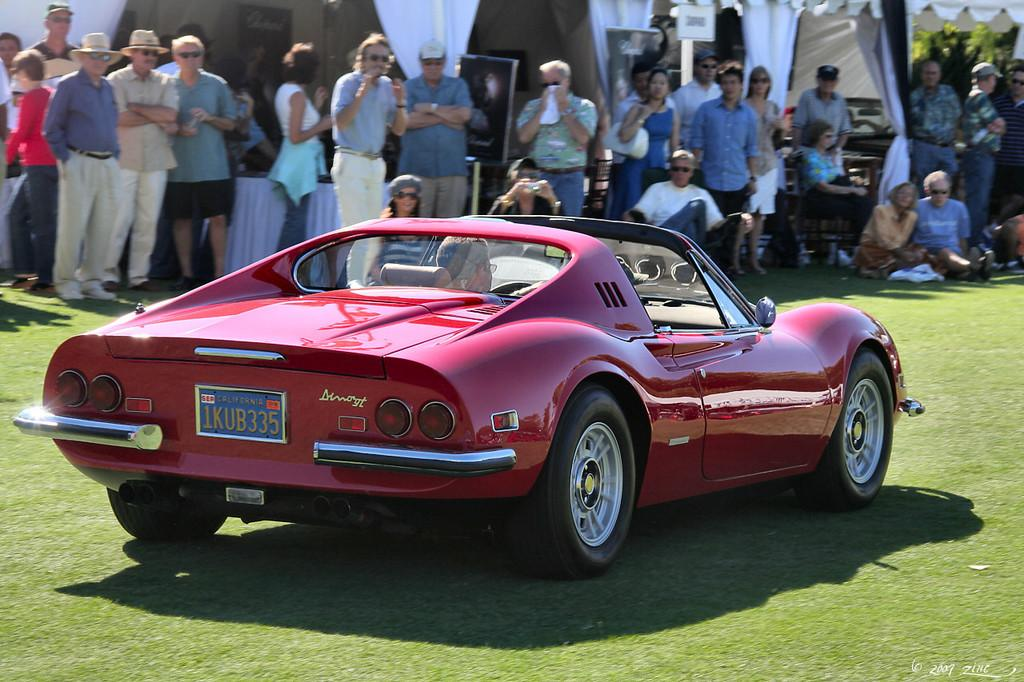What is located on the ground in the image? There is a vehicle on the ground in the image. What can be seen in the background of the image? There is a group of people and some objects present in the background of the image. Can you describe the curtains visible in the background of the image? The curtains visible curtains visible in the background of the image are a part of the setting. How many dinosaurs can be seen walking through the gate in the image? There are no dinosaurs or gates present in the image. 